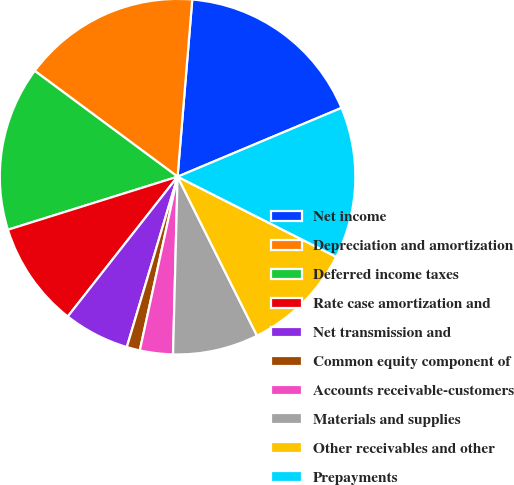Convert chart to OTSL. <chart><loc_0><loc_0><loc_500><loc_500><pie_chart><fcel>Net income<fcel>Depreciation and amortization<fcel>Deferred income taxes<fcel>Rate case amortization and<fcel>Net transmission and<fcel>Common equity component of<fcel>Accounts receivable-customers<fcel>Materials and supplies<fcel>Other receivables and other<fcel>Prepayments<nl><fcel>17.36%<fcel>16.17%<fcel>14.97%<fcel>9.58%<fcel>5.99%<fcel>1.2%<fcel>3.0%<fcel>7.78%<fcel>10.18%<fcel>13.77%<nl></chart> 